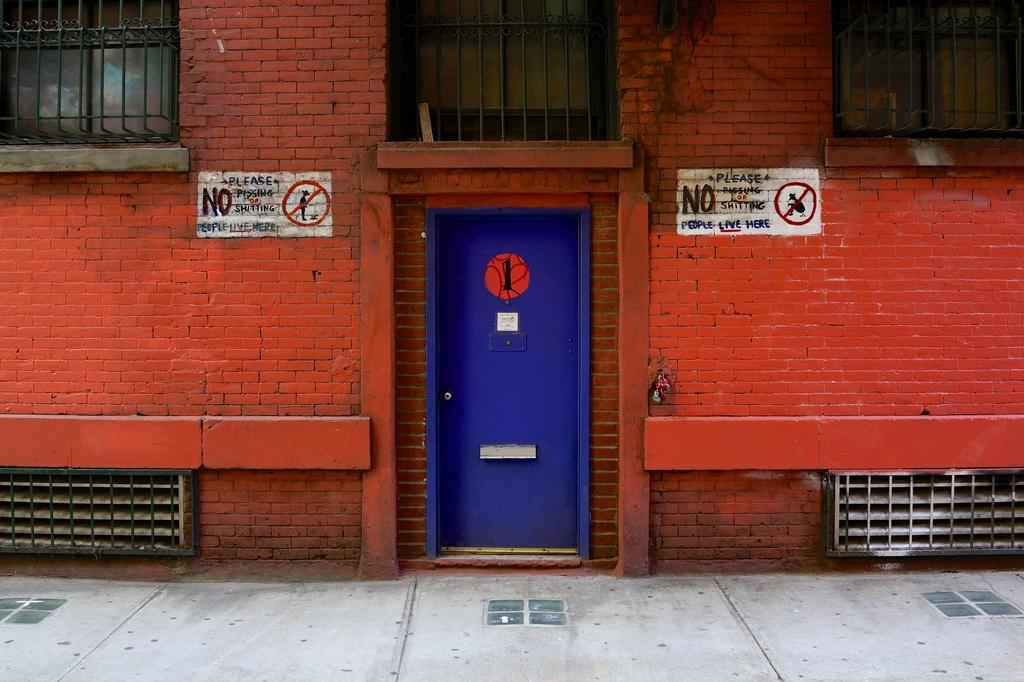What is in the foreground of the image? There is a pavement in the foreground of the image. What can be seen in the background of the image? There is a red building in the background of the image. What features does the building have? The building has windows and a blue door. What decorations are on the building? There are paintings on the building. How does the building express fear in the image? The building does not express fear in the image; it is an inanimate object. Can you tell me how many times the person in the image sneezes? There is no person present in the image, so it is impossible to determine how many times they sneeze. 